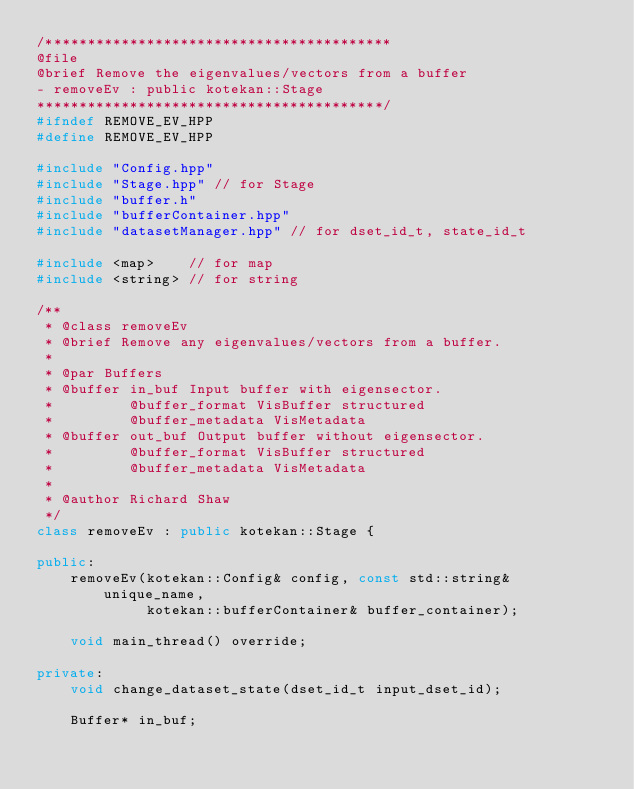Convert code to text. <code><loc_0><loc_0><loc_500><loc_500><_C++_>/*****************************************
@file
@brief Remove the eigenvalues/vectors from a buffer
- removeEv : public kotekan::Stage
*****************************************/
#ifndef REMOVE_EV_HPP
#define REMOVE_EV_HPP

#include "Config.hpp"
#include "Stage.hpp" // for Stage
#include "buffer.h"
#include "bufferContainer.hpp"
#include "datasetManager.hpp" // for dset_id_t, state_id_t

#include <map>    // for map
#include <string> // for string

/**
 * @class removeEv
 * @brief Remove any eigenvalues/vectors from a buffer.
 *
 * @par Buffers
 * @buffer in_buf Input buffer with eigensector.
 *         @buffer_format VisBuffer structured
 *         @buffer_metadata VisMetadata
 * @buffer out_buf Output buffer without eigensector.
 *         @buffer_format VisBuffer structured
 *         @buffer_metadata VisMetadata
 *
 * @author Richard Shaw
 */
class removeEv : public kotekan::Stage {

public:
    removeEv(kotekan::Config& config, const std::string& unique_name,
             kotekan::bufferContainer& buffer_container);

    void main_thread() override;

private:
    void change_dataset_state(dset_id_t input_dset_id);

    Buffer* in_buf;</code> 